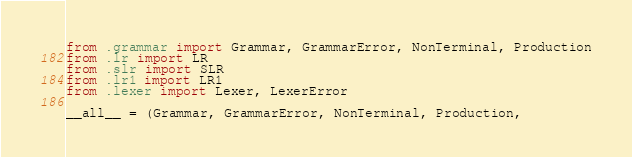Convert code to text. <code><loc_0><loc_0><loc_500><loc_500><_Python_>from .grammar import Grammar, GrammarError, NonTerminal, Production
from .lr import LR
from .slr import SLR
from .lr1 import LR1
from .lexer import Lexer, LexerError

__all__ = (Grammar, GrammarError, NonTerminal, Production,</code> 